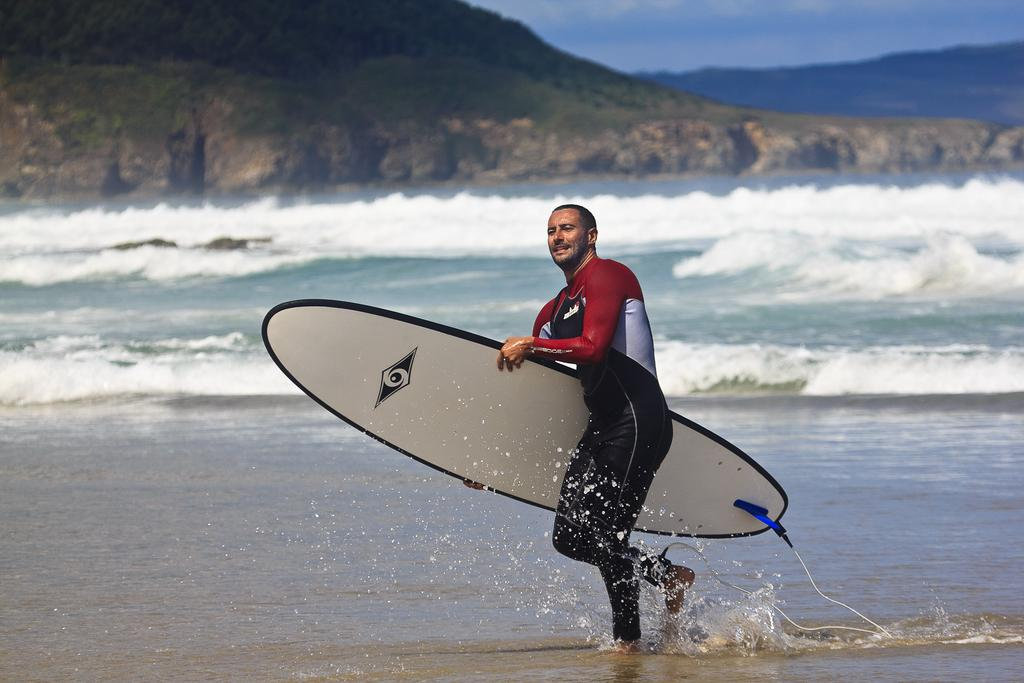What is the man in the image holding? The man is holding a surfboard. What is the man doing in the image? The man is walking in the water. What can be seen in the background of the image? There is water, mountains, and clouds in the sky visible in the background of the image. What type of powder is being used by the ladybug in the image? There is no ladybug present in the image, and therefore no powder can be observed. 